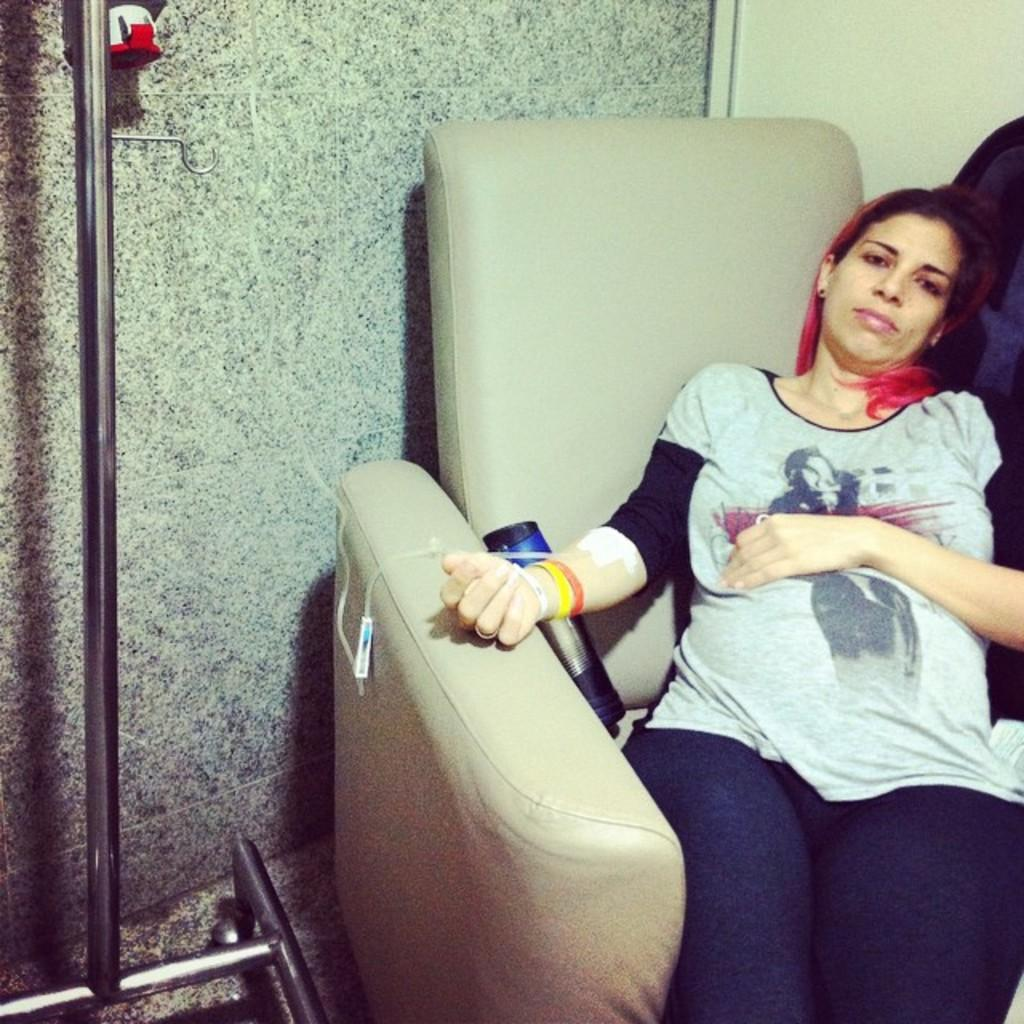What is the woman doing in the image? The woman is sitting on the couch in the image. What object can be seen near the woman? There is a bottle in the image. What is located beside the couch in the image? There is a stand beside the couch in the image. What can be seen in the background of the image? There is a wall in the background of the image. How does the woman's dad contribute to pollution in the image? There is no mention of the woman's dad or pollution in the image, so it is not possible to answer that question. 